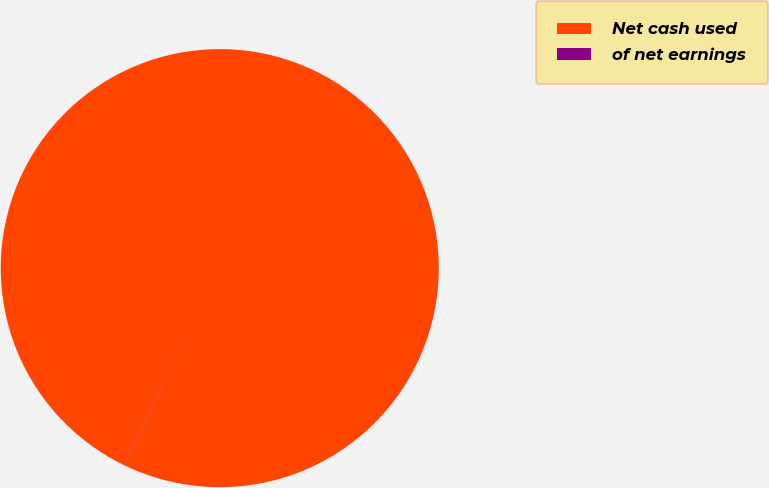Convert chart to OTSL. <chart><loc_0><loc_0><loc_500><loc_500><pie_chart><fcel>Net cash used<fcel>of net earnings<nl><fcel>99.98%<fcel>0.02%<nl></chart> 